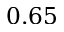Convert formula to latex. <formula><loc_0><loc_0><loc_500><loc_500>0 . 6 5</formula> 